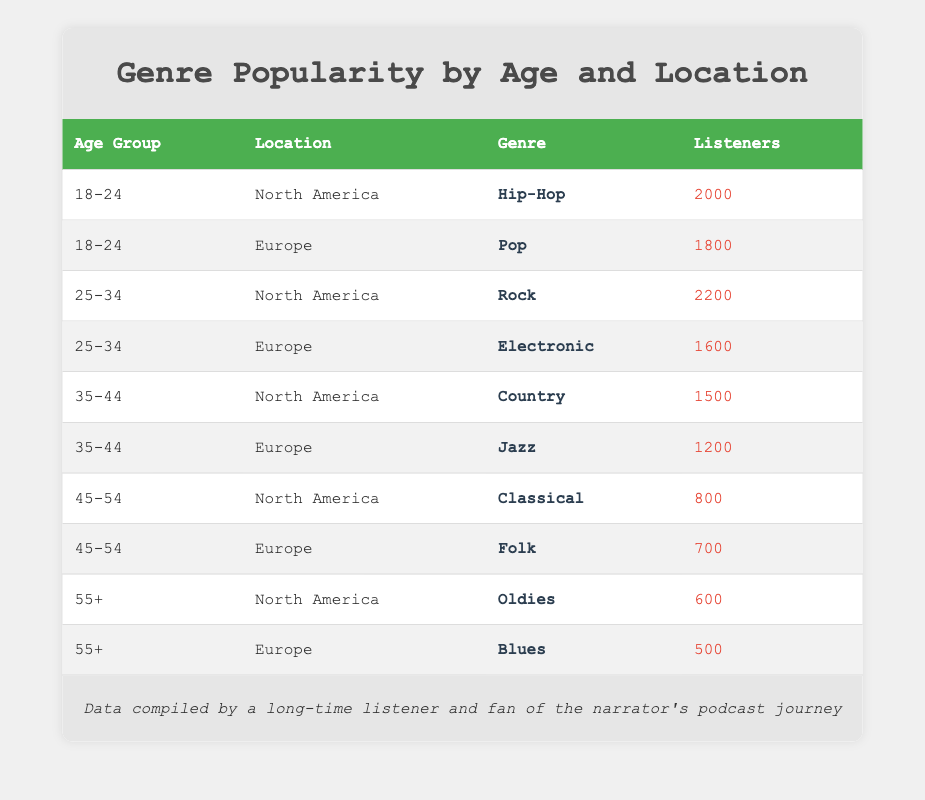What genre is most popular among the 18-24 age group in North America? The table shows that the genre for the 18-24 age group in North America is Hip-Hop, which has 2000 listeners.
Answer: Hip-Hop Which location has more listeners for the 25-34 age group: North America or Europe? When comparing the two, North America has 2200 listeners for Rock in the 25-34 age group, while Europe has 1600 listeners for Electronic. Thus, North America has more listeners.
Answer: North America Is the genre Jazz popular among the 35-44 age group in Europe? According to the table, the 35-44 age group in Europe listens to Jazz, which has 1200 listeners, indicating that it is popular.
Answer: Yes What is the total number of listeners for all genres in the North America region? By adding the listeners in North America: 2000 (Hip-Hop) + 2200 (Rock) + 1500 (Country) + 800 (Classical) + 600 (Oldies) = 8300 total listeners in North America.
Answer: 8300 Which age group has the lowest audience in North America? From the table, the age group 55+ has the lowest audience in North America with 600 listeners for Oldies.
Answer: 55+ What is the average number of listeners for the Pop genre across both regions? Pop is only listed in Europe with 1800 listeners. Since there are no listeners in North America for this genre, the average remains 1800.
Answer: 1800 Is there a genre that has the same number of listeners for both age groups 45-54 in North America and Europe? The table shows that North America has 800 listeners for Classical and Europe has 700 listeners for Folk, meaning that there is no genre with the same number of listeners in both regions.
Answer: No Which genre has more listeners in Europe: Folk or Jazz? The table indicates that Folk has 700 listeners while Jazz has 1200 listeners in Europe, thus Jazz has more listeners than Folk.
Answer: Jazz What is the difference in listeners between the genres Oldies and Blues? Oldies in North America has 600 listeners, whereas Blues in Europe has 500 listeners. The difference is calculated as 600 - 500 = 100 listeners.
Answer: 100 